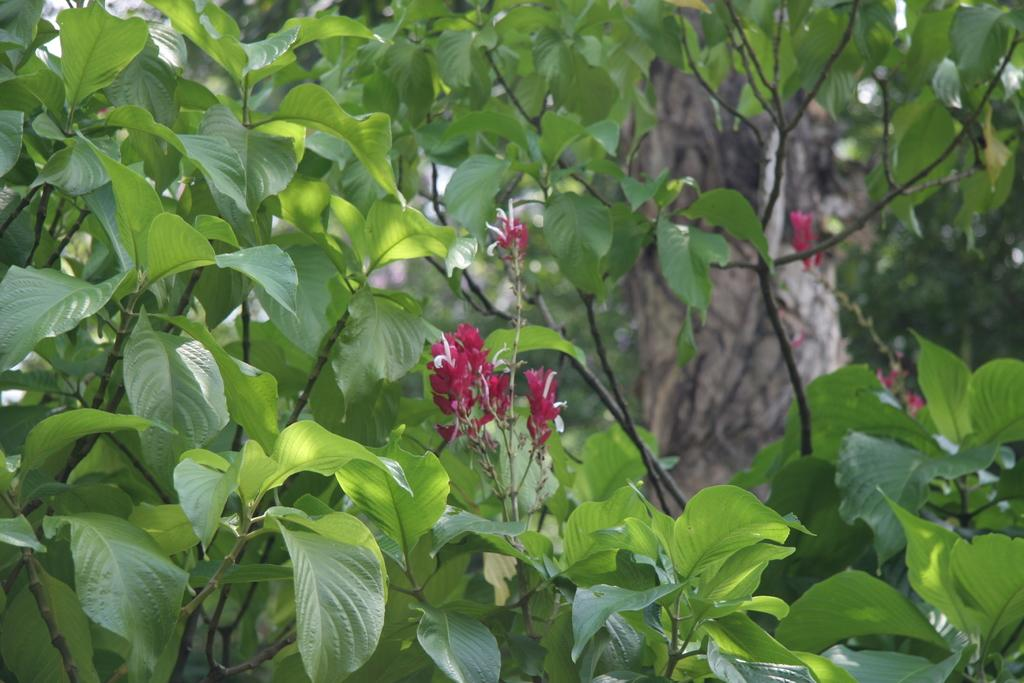What type of plant elements can be seen in the image? There are branches of plants in the image. What additional features can be observed on the branches? There are flowers visible between the branches. What part of the plant is visible in the background of the image? There is a tree trunk in the background of the image. How many pieces of cheese are scattered around the kittens in the image? There are no kittens or cheese present in the image; it features branches of plants with flowers and a tree trunk in the background. 